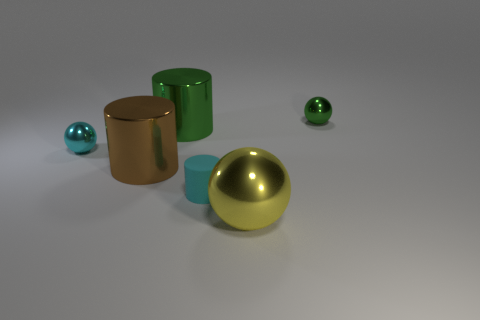What could be the purpose of arranging these objects like this? This arrangement of objects could serve various purposes. It might be a visualization intended to demonstrate the properties of light and reflection or used in a physics lesson about optics. Alternatively, it could be an artistic setup designed to explore visual aesthetics involving color harmony, contrast, and the interplay of different surface textures. 